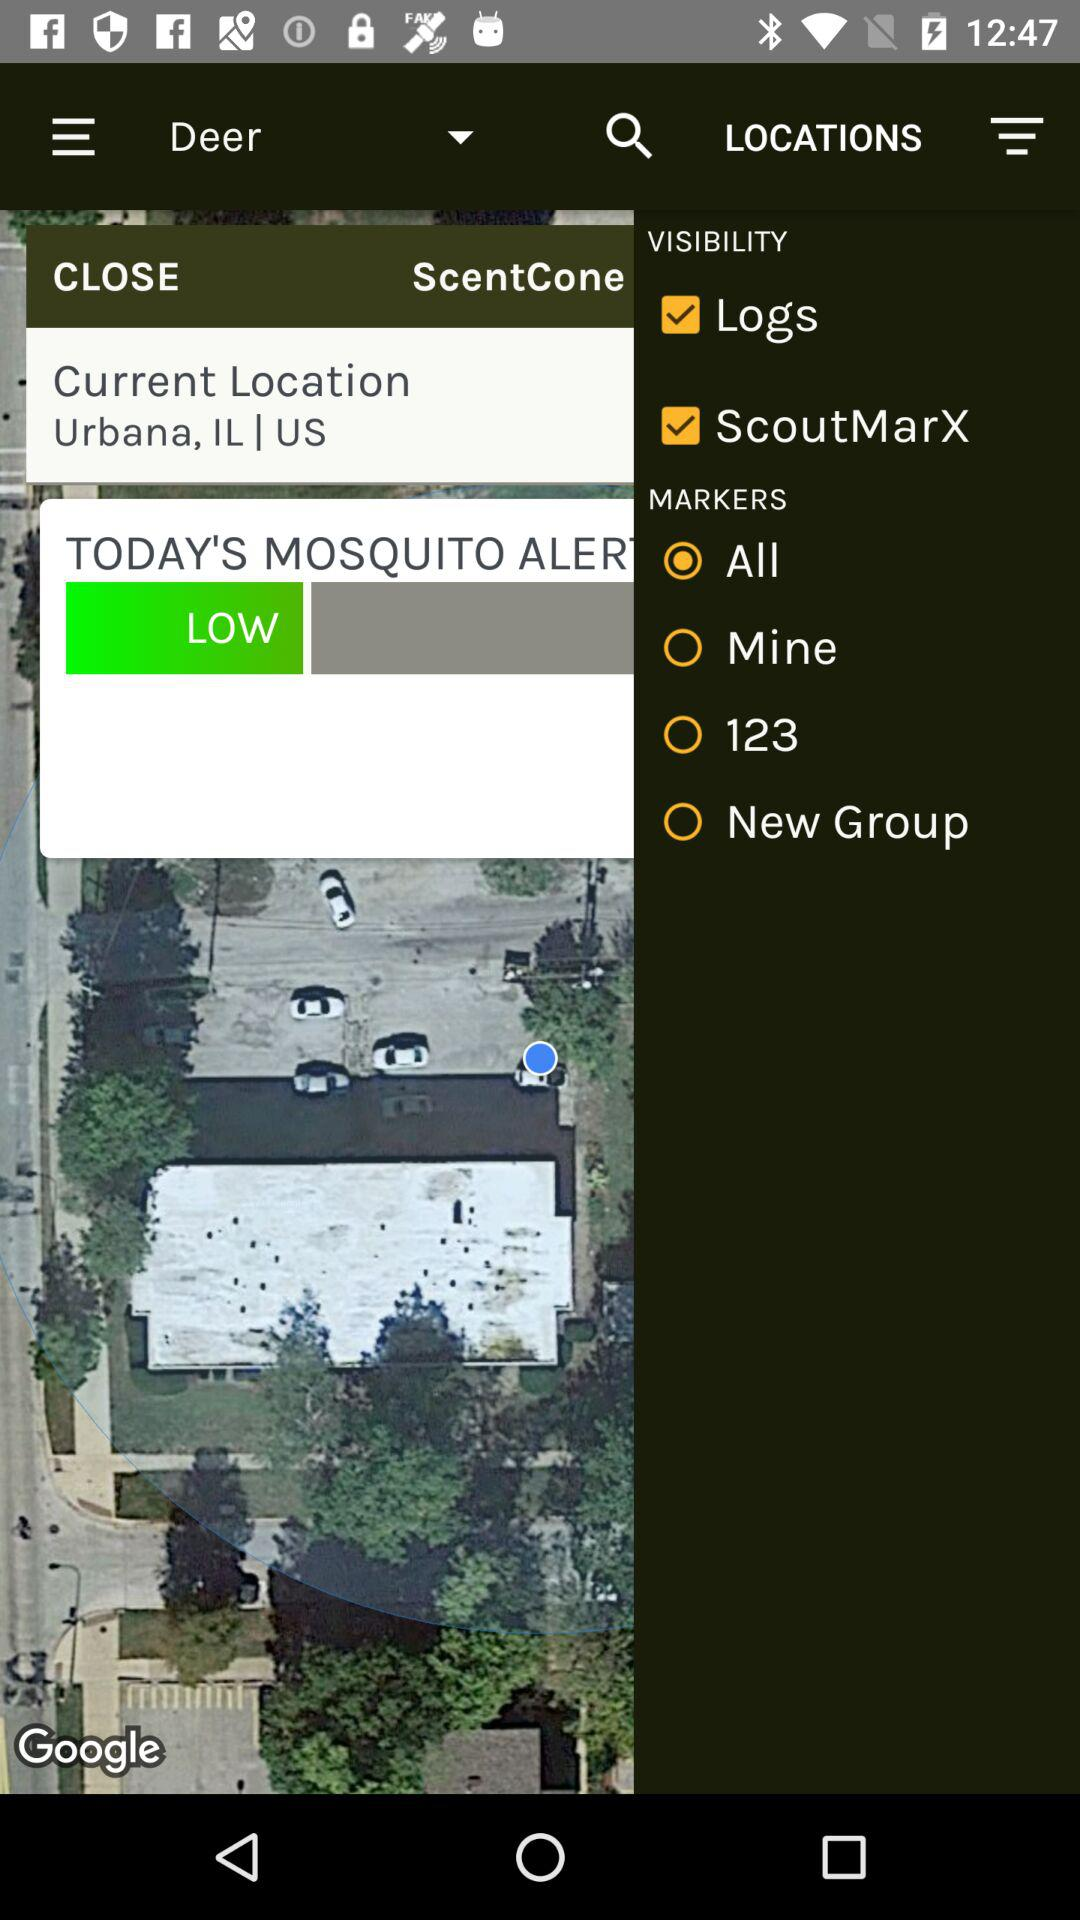Which visibility options are checked? The checked visibility options are "Logs" and "ScoutMarX". 